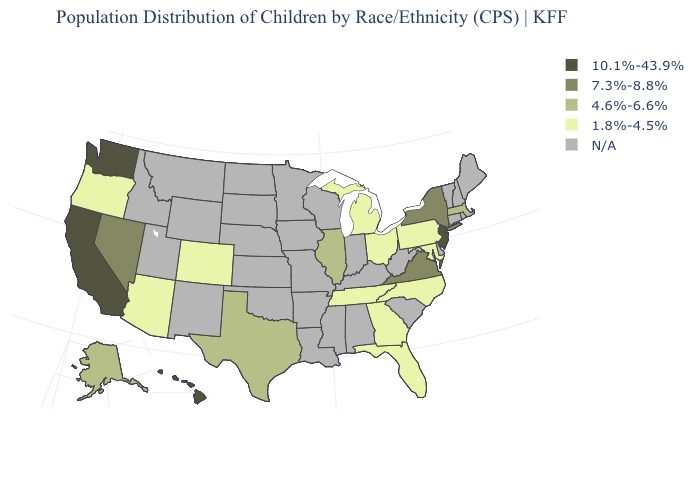Name the states that have a value in the range 10.1%-43.9%?
Answer briefly. California, Hawaii, New Jersey, Washington. Does the map have missing data?
Be succinct. Yes. Among the states that border Michigan , which have the highest value?
Answer briefly. Ohio. What is the value of Alaska?
Short answer required. 4.6%-6.6%. Does California have the highest value in the USA?
Give a very brief answer. Yes. How many symbols are there in the legend?
Write a very short answer. 5. What is the value of California?
Keep it brief. 10.1%-43.9%. Name the states that have a value in the range 10.1%-43.9%?
Keep it brief. California, Hawaii, New Jersey, Washington. What is the lowest value in the USA?
Be succinct. 1.8%-4.5%. Among the states that border New York , which have the highest value?
Give a very brief answer. New Jersey. Name the states that have a value in the range 1.8%-4.5%?
Concise answer only. Arizona, Colorado, Florida, Georgia, Maryland, Michigan, North Carolina, Ohio, Oregon, Pennsylvania, Tennessee. Among the states that border Pennsylvania , which have the highest value?
Answer briefly. New Jersey. What is the lowest value in the South?
Give a very brief answer. 1.8%-4.5%. Is the legend a continuous bar?
Concise answer only. No. 